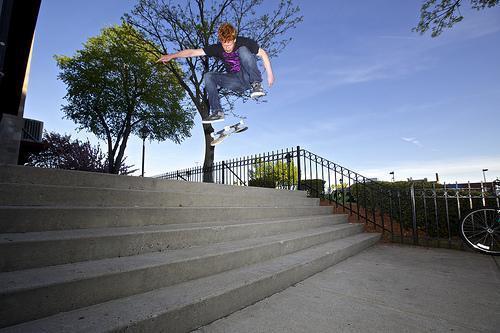How many people are there?
Give a very brief answer. 1. 